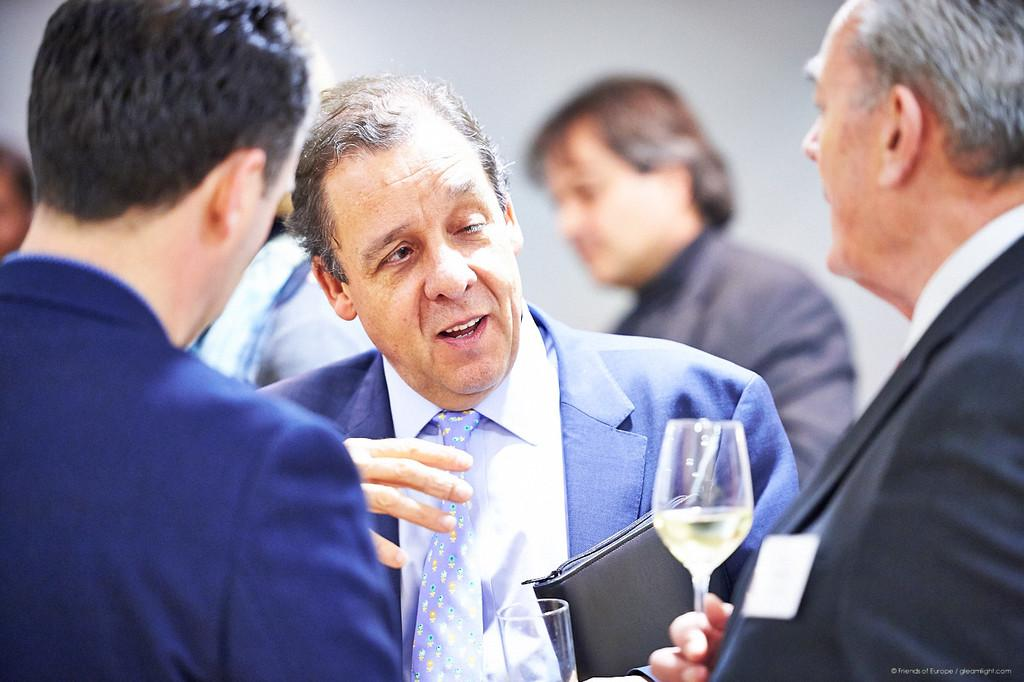How many people are in the image? There are persons in the image, but the exact number is not specified. What is one person doing with their hand? One person is holding a glass with their hand. What object related to work or documentation is present in the image? There is a file in the image. What can be seen in the background of the image? There is a wall in the background of the image. What color is the balloon that is floating near the persons in the image? There is no balloon present in the image. What type of stem is visible on the table in the image? There is no stem visible on the table in the image. 